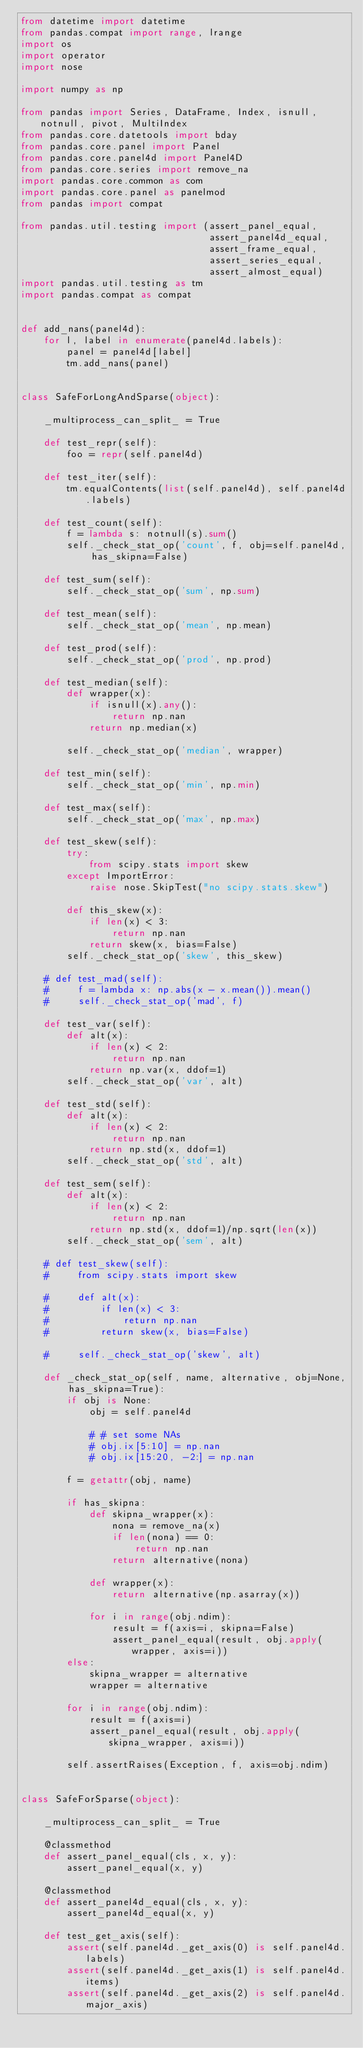<code> <loc_0><loc_0><loc_500><loc_500><_Python_>from datetime import datetime
from pandas.compat import range, lrange
import os
import operator
import nose

import numpy as np

from pandas import Series, DataFrame, Index, isnull, notnull, pivot, MultiIndex
from pandas.core.datetools import bday
from pandas.core.panel import Panel
from pandas.core.panel4d import Panel4D
from pandas.core.series import remove_na
import pandas.core.common as com
import pandas.core.panel as panelmod
from pandas import compat

from pandas.util.testing import (assert_panel_equal,
                                 assert_panel4d_equal,
                                 assert_frame_equal,
                                 assert_series_equal,
                                 assert_almost_equal)
import pandas.util.testing as tm
import pandas.compat as compat


def add_nans(panel4d):
    for l, label in enumerate(panel4d.labels):
        panel = panel4d[label]
        tm.add_nans(panel)


class SafeForLongAndSparse(object):

    _multiprocess_can_split_ = True

    def test_repr(self):
        foo = repr(self.panel4d)

    def test_iter(self):
        tm.equalContents(list(self.panel4d), self.panel4d.labels)

    def test_count(self):
        f = lambda s: notnull(s).sum()
        self._check_stat_op('count', f, obj=self.panel4d, has_skipna=False)

    def test_sum(self):
        self._check_stat_op('sum', np.sum)

    def test_mean(self):
        self._check_stat_op('mean', np.mean)

    def test_prod(self):
        self._check_stat_op('prod', np.prod)

    def test_median(self):
        def wrapper(x):
            if isnull(x).any():
                return np.nan
            return np.median(x)

        self._check_stat_op('median', wrapper)

    def test_min(self):
        self._check_stat_op('min', np.min)

    def test_max(self):
        self._check_stat_op('max', np.max)

    def test_skew(self):
        try:
            from scipy.stats import skew
        except ImportError:
            raise nose.SkipTest("no scipy.stats.skew")

        def this_skew(x):
            if len(x) < 3:
                return np.nan
            return skew(x, bias=False)
        self._check_stat_op('skew', this_skew)

    # def test_mad(self):
    #     f = lambda x: np.abs(x - x.mean()).mean()
    #     self._check_stat_op('mad', f)

    def test_var(self):
        def alt(x):
            if len(x) < 2:
                return np.nan
            return np.var(x, ddof=1)
        self._check_stat_op('var', alt)

    def test_std(self):
        def alt(x):
            if len(x) < 2:
                return np.nan
            return np.std(x, ddof=1)
        self._check_stat_op('std', alt)

    def test_sem(self):
        def alt(x):
            if len(x) < 2:
                return np.nan
            return np.std(x, ddof=1)/np.sqrt(len(x))
        self._check_stat_op('sem', alt)

    # def test_skew(self):
    #     from scipy.stats import skew

    #     def alt(x):
    #         if len(x) < 3:
    #             return np.nan
    #         return skew(x, bias=False)

    #     self._check_stat_op('skew', alt)

    def _check_stat_op(self, name, alternative, obj=None, has_skipna=True):
        if obj is None:
            obj = self.panel4d

            # # set some NAs
            # obj.ix[5:10] = np.nan
            # obj.ix[15:20, -2:] = np.nan

        f = getattr(obj, name)

        if has_skipna:
            def skipna_wrapper(x):
                nona = remove_na(x)
                if len(nona) == 0:
                    return np.nan
                return alternative(nona)

            def wrapper(x):
                return alternative(np.asarray(x))

            for i in range(obj.ndim):
                result = f(axis=i, skipna=False)
                assert_panel_equal(result, obj.apply(wrapper, axis=i))
        else:
            skipna_wrapper = alternative
            wrapper = alternative

        for i in range(obj.ndim):
            result = f(axis=i)
            assert_panel_equal(result, obj.apply(skipna_wrapper, axis=i))

        self.assertRaises(Exception, f, axis=obj.ndim)


class SafeForSparse(object):

    _multiprocess_can_split_ = True

    @classmethod
    def assert_panel_equal(cls, x, y):
        assert_panel_equal(x, y)

    @classmethod
    def assert_panel4d_equal(cls, x, y):
        assert_panel4d_equal(x, y)

    def test_get_axis(self):
        assert(self.panel4d._get_axis(0) is self.panel4d.labels)
        assert(self.panel4d._get_axis(1) is self.panel4d.items)
        assert(self.panel4d._get_axis(2) is self.panel4d.major_axis)</code> 